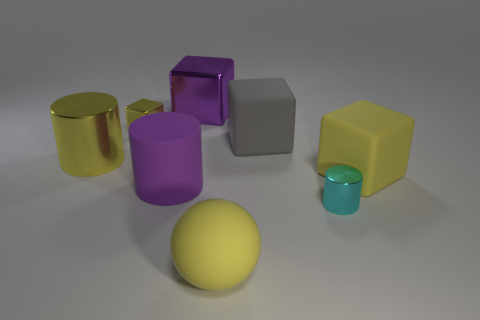What number of other objects are there of the same material as the big yellow ball?
Your answer should be compact. 3. How big is the yellow rubber block?
Provide a short and direct response. Large. What number of other things are the same color as the tiny metal cylinder?
Your response must be concise. 0. There is a cylinder that is right of the small cube and left of the big matte sphere; what color is it?
Provide a succinct answer. Purple. What number of tiny metallic blocks are there?
Your response must be concise. 1. Are the large yellow cylinder and the cyan cylinder made of the same material?
Ensure brevity in your answer.  Yes. What is the shape of the yellow object that is in front of the rubber cube that is in front of the metal cylinder on the left side of the cyan shiny cylinder?
Your response must be concise. Sphere. Are the big object that is right of the tiny cylinder and the big cylinder to the left of the tiny yellow metallic cube made of the same material?
Provide a succinct answer. No. What is the big purple block made of?
Your answer should be compact. Metal. How many other purple metallic objects have the same shape as the big purple shiny thing?
Make the answer very short. 0. 